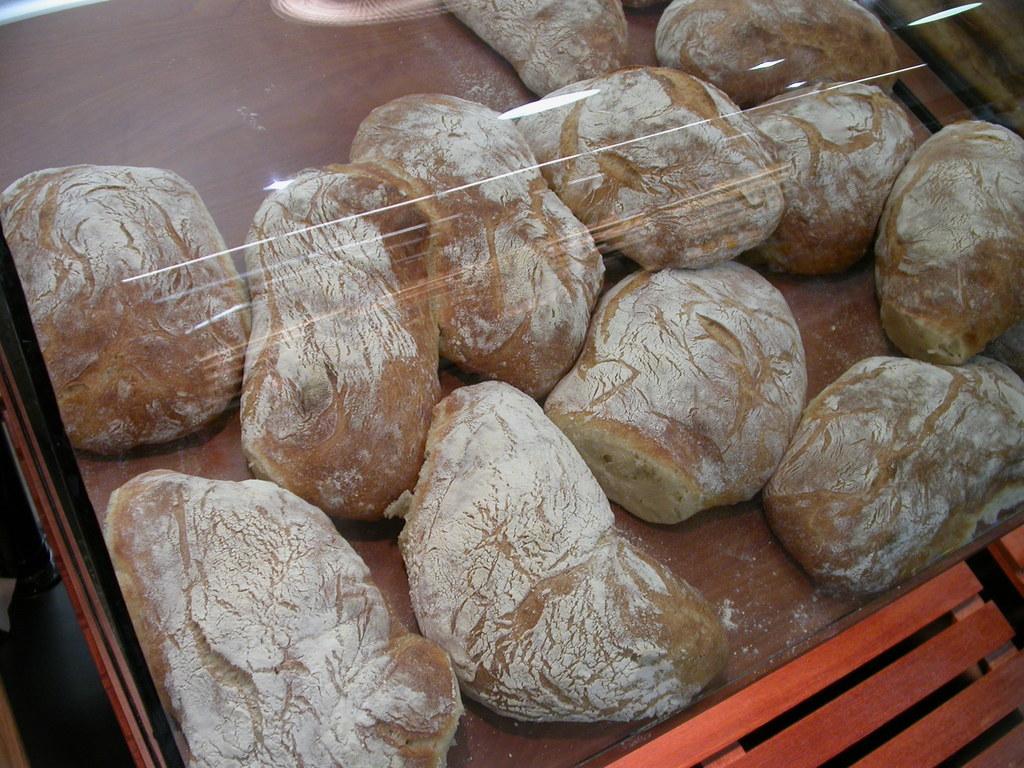In one or two sentences, can you explain what this image depicts? In this image in the center there are some food items, and at the bottom there is a table. 